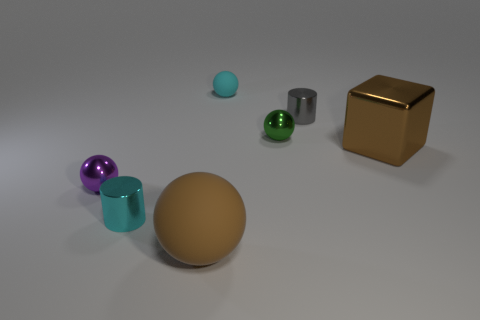Subtract all tiny cyan balls. How many balls are left? 3 Subtract 1 balls. How many balls are left? 3 Subtract all cyan balls. How many balls are left? 3 Add 3 tiny red shiny spheres. How many objects exist? 10 Subtract all purple spheres. Subtract all blue cubes. How many spheres are left? 3 Subtract all spheres. How many objects are left? 3 Add 5 large gray matte spheres. How many large gray matte spheres exist? 5 Subtract 0 cyan cubes. How many objects are left? 7 Subtract all small cyan things. Subtract all big brown matte spheres. How many objects are left? 4 Add 7 small purple metallic spheres. How many small purple metallic spheres are left? 8 